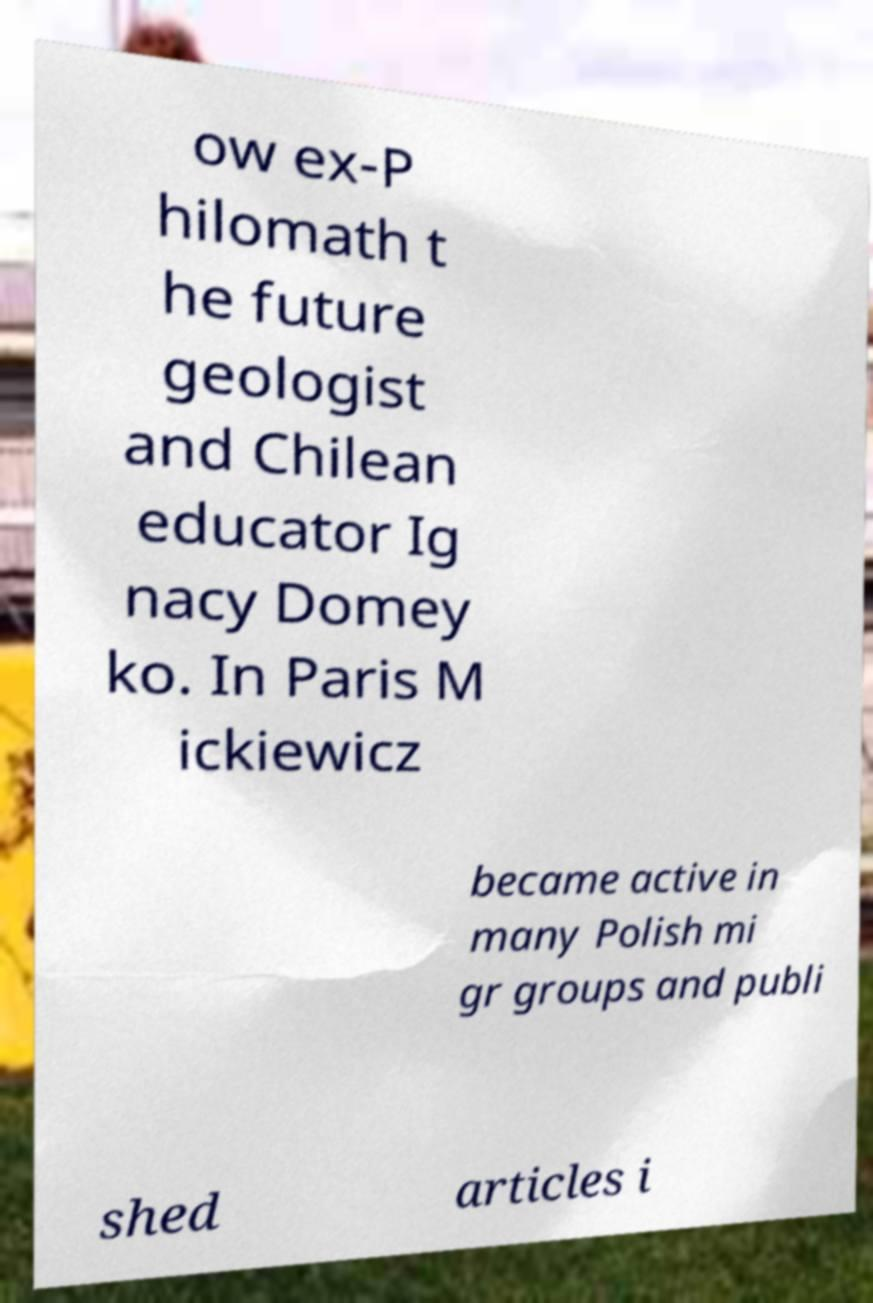Can you accurately transcribe the text from the provided image for me? ow ex-P hilomath t he future geologist and Chilean educator Ig nacy Domey ko. In Paris M ickiewicz became active in many Polish mi gr groups and publi shed articles i 